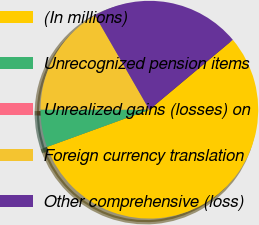Convert chart to OTSL. <chart><loc_0><loc_0><loc_500><loc_500><pie_chart><fcel>(In millions)<fcel>Unrecognized pension items<fcel>Unrealized gains (losses) on<fcel>Foreign currency translation<fcel>Other comprehensive (loss)<nl><fcel>55.55%<fcel>5.56%<fcel>0.0%<fcel>16.67%<fcel>22.22%<nl></chart> 